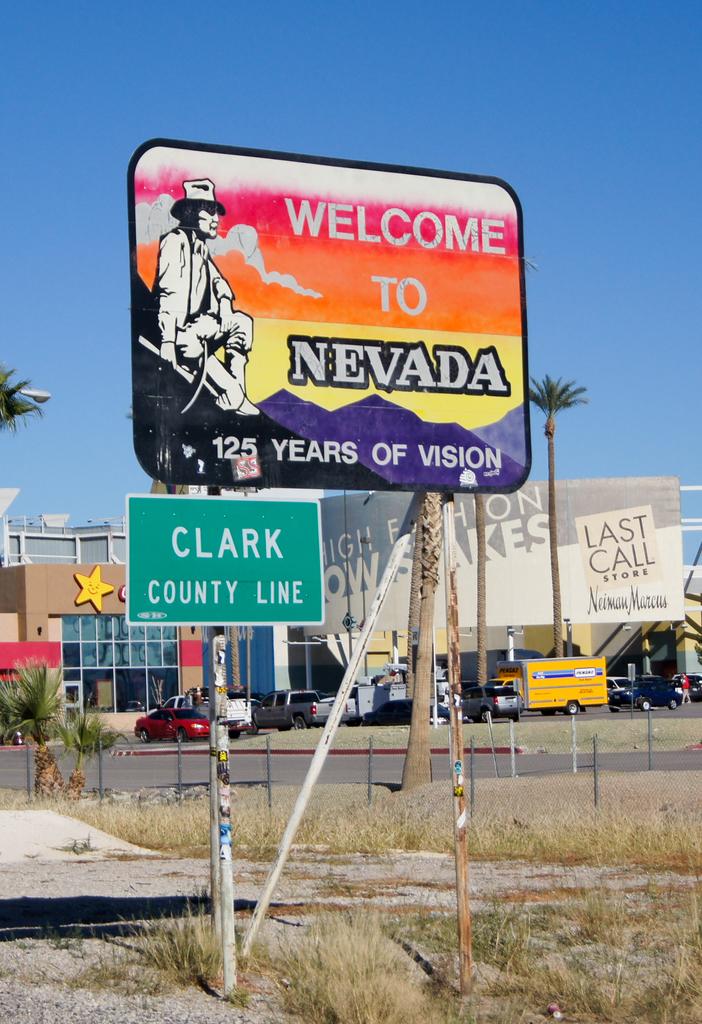Welcome to which state?
Your answer should be very brief. Nevada. 